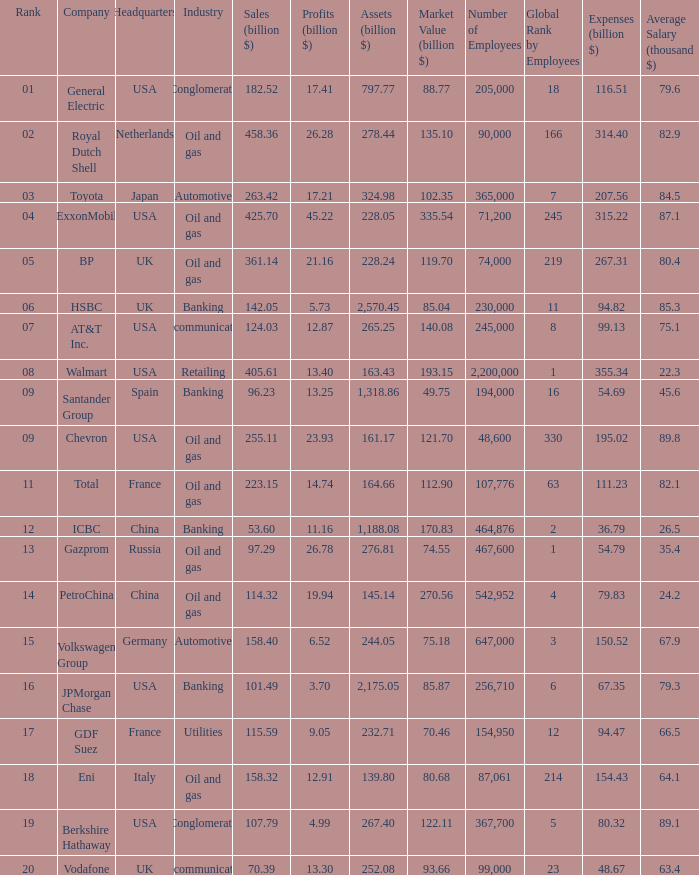Name the highest Profits (billion $) which has a Company of walmart? 13.4. 